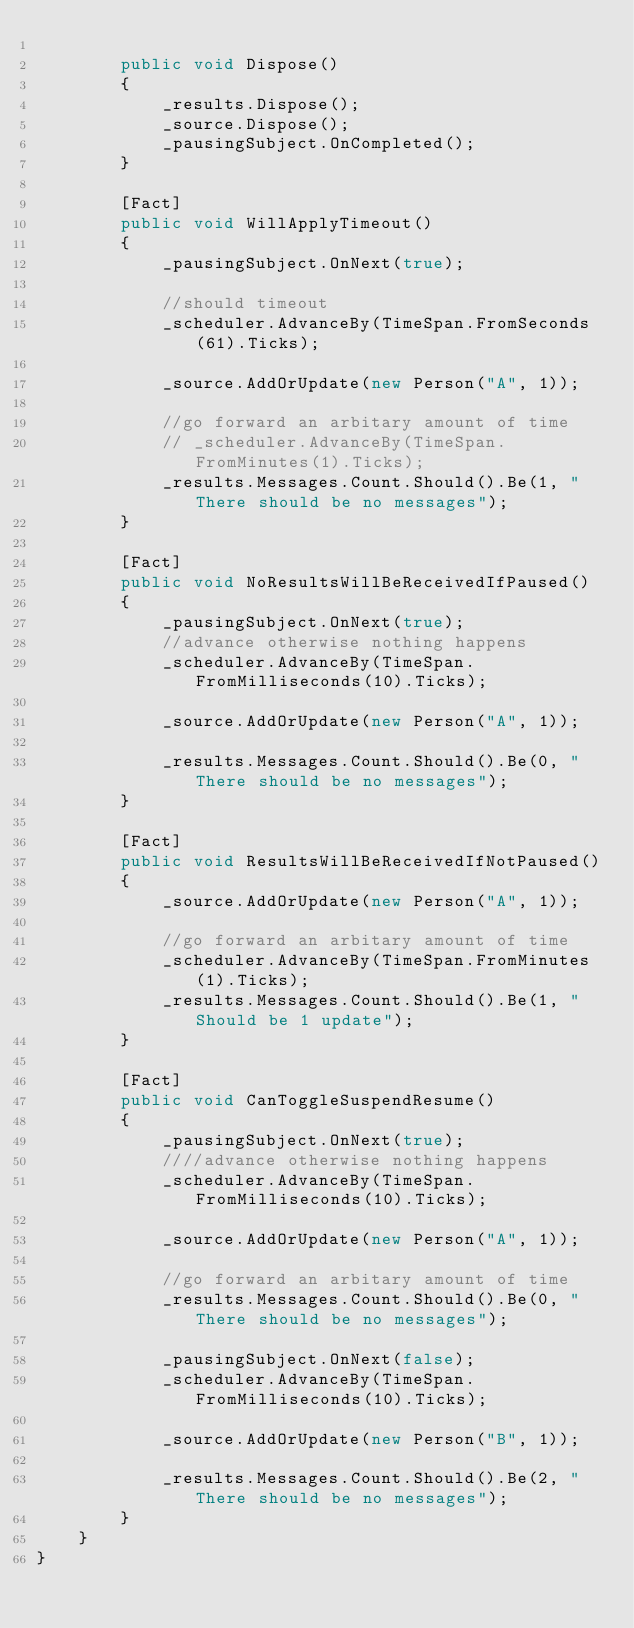Convert code to text. <code><loc_0><loc_0><loc_500><loc_500><_C#_>
        public void Dispose()
        {
            _results.Dispose();
            _source.Dispose();
            _pausingSubject.OnCompleted();
        }

        [Fact]
        public void WillApplyTimeout()
        {
            _pausingSubject.OnNext(true);

            //should timeout 
            _scheduler.AdvanceBy(TimeSpan.FromSeconds(61).Ticks);

            _source.AddOrUpdate(new Person("A", 1));

            //go forward an arbitary amount of time
            // _scheduler.AdvanceBy(TimeSpan.FromMinutes(1).Ticks);
            _results.Messages.Count.Should().Be(1, "There should be no messages");
        }

        [Fact]
        public void NoResultsWillBeReceivedIfPaused()
        {
            _pausingSubject.OnNext(true);
            //advance otherwise nothing happens
            _scheduler.AdvanceBy(TimeSpan.FromMilliseconds(10).Ticks);

            _source.AddOrUpdate(new Person("A", 1));

            _results.Messages.Count.Should().Be(0, "There should be no messages");
        }

        [Fact]
        public void ResultsWillBeReceivedIfNotPaused()
        {
            _source.AddOrUpdate(new Person("A", 1));

            //go forward an arbitary amount of time
            _scheduler.AdvanceBy(TimeSpan.FromMinutes(1).Ticks);
            _results.Messages.Count.Should().Be(1, "Should be 1 update");
        }

        [Fact]
        public void CanToggleSuspendResume()
        {
            _pausingSubject.OnNext(true);
            ////advance otherwise nothing happens
            _scheduler.AdvanceBy(TimeSpan.FromMilliseconds(10).Ticks);

            _source.AddOrUpdate(new Person("A", 1));

            //go forward an arbitary amount of time
            _results.Messages.Count.Should().Be(0, "There should be no messages");

            _pausingSubject.OnNext(false);
            _scheduler.AdvanceBy(TimeSpan.FromMilliseconds(10).Ticks);

            _source.AddOrUpdate(new Person("B", 1));

            _results.Messages.Count.Should().Be(2, "There should be no messages");
        }
    }
}
</code> 